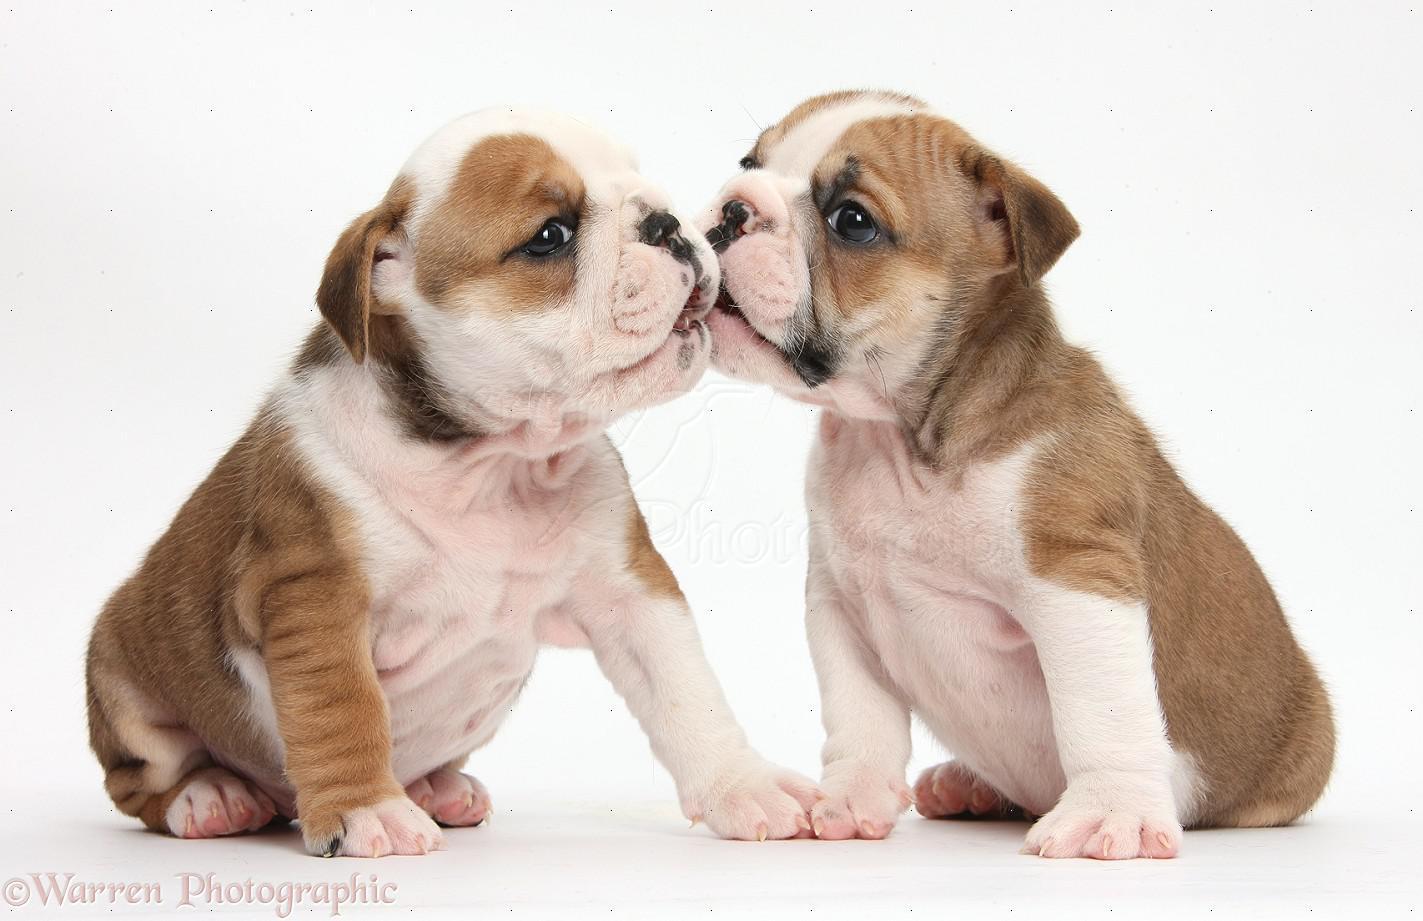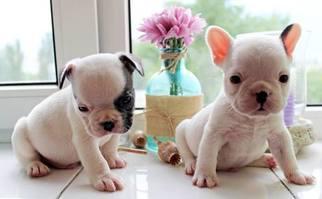The first image is the image on the left, the second image is the image on the right. Considering the images on both sides, is "Left image shows side-by-side dogs, with at least one dog sitting upright." valid? Answer yes or no. Yes. The first image is the image on the left, the second image is the image on the right. Analyze the images presented: Is the assertion "In one image, two dogs are touching one another, with at least one of the dogs touching the other with its mouth" valid? Answer yes or no. Yes. 